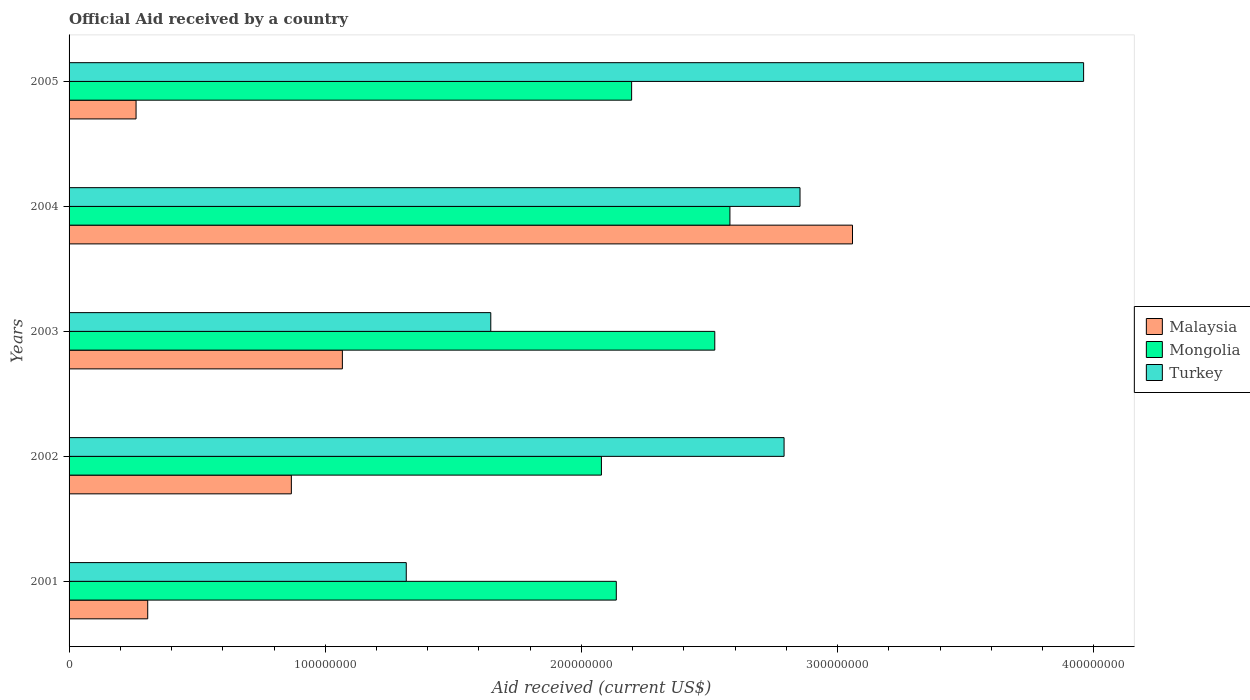How many groups of bars are there?
Your answer should be very brief. 5. How many bars are there on the 1st tick from the top?
Provide a short and direct response. 3. What is the net official aid received in Mongolia in 2005?
Make the answer very short. 2.20e+08. Across all years, what is the maximum net official aid received in Mongolia?
Provide a succinct answer. 2.58e+08. Across all years, what is the minimum net official aid received in Turkey?
Offer a very short reply. 1.32e+08. In which year was the net official aid received in Turkey minimum?
Your answer should be compact. 2001. What is the total net official aid received in Turkey in the graph?
Ensure brevity in your answer.  1.26e+09. What is the difference between the net official aid received in Mongolia in 2003 and that in 2005?
Your answer should be compact. 3.25e+07. What is the difference between the net official aid received in Malaysia in 2004 and the net official aid received in Mongolia in 2003?
Offer a very short reply. 5.38e+07. What is the average net official aid received in Malaysia per year?
Offer a terse response. 1.11e+08. In the year 2004, what is the difference between the net official aid received in Turkey and net official aid received in Mongolia?
Your answer should be compact. 2.74e+07. In how many years, is the net official aid received in Malaysia greater than 180000000 US$?
Ensure brevity in your answer.  1. What is the ratio of the net official aid received in Malaysia in 2002 to that in 2003?
Make the answer very short. 0.81. Is the net official aid received in Malaysia in 2001 less than that in 2002?
Your answer should be very brief. Yes. What is the difference between the highest and the second highest net official aid received in Turkey?
Offer a terse response. 1.11e+08. What is the difference between the highest and the lowest net official aid received in Mongolia?
Offer a terse response. 5.02e+07. In how many years, is the net official aid received in Mongolia greater than the average net official aid received in Mongolia taken over all years?
Ensure brevity in your answer.  2. What does the 1st bar from the top in 2001 represents?
Keep it short and to the point. Turkey. What does the 2nd bar from the bottom in 2004 represents?
Provide a short and direct response. Mongolia. Is it the case that in every year, the sum of the net official aid received in Malaysia and net official aid received in Mongolia is greater than the net official aid received in Turkey?
Ensure brevity in your answer.  No. Are all the bars in the graph horizontal?
Offer a terse response. Yes. How many years are there in the graph?
Offer a terse response. 5. What is the difference between two consecutive major ticks on the X-axis?
Provide a short and direct response. 1.00e+08. Does the graph contain any zero values?
Ensure brevity in your answer.  No. Does the graph contain grids?
Keep it short and to the point. No. Where does the legend appear in the graph?
Your response must be concise. Center right. How many legend labels are there?
Offer a terse response. 3. How are the legend labels stacked?
Offer a terse response. Vertical. What is the title of the graph?
Offer a very short reply. Official Aid received by a country. Does "Lithuania" appear as one of the legend labels in the graph?
Your answer should be compact. No. What is the label or title of the X-axis?
Provide a succinct answer. Aid received (current US$). What is the Aid received (current US$) in Malaysia in 2001?
Keep it short and to the point. 3.07e+07. What is the Aid received (current US$) of Mongolia in 2001?
Ensure brevity in your answer.  2.14e+08. What is the Aid received (current US$) of Turkey in 2001?
Give a very brief answer. 1.32e+08. What is the Aid received (current US$) of Malaysia in 2002?
Ensure brevity in your answer.  8.68e+07. What is the Aid received (current US$) of Mongolia in 2002?
Your response must be concise. 2.08e+08. What is the Aid received (current US$) in Turkey in 2002?
Provide a short and direct response. 2.79e+08. What is the Aid received (current US$) of Malaysia in 2003?
Ensure brevity in your answer.  1.07e+08. What is the Aid received (current US$) in Mongolia in 2003?
Keep it short and to the point. 2.52e+08. What is the Aid received (current US$) of Turkey in 2003?
Offer a very short reply. 1.65e+08. What is the Aid received (current US$) in Malaysia in 2004?
Provide a short and direct response. 3.06e+08. What is the Aid received (current US$) of Mongolia in 2004?
Offer a terse response. 2.58e+08. What is the Aid received (current US$) in Turkey in 2004?
Ensure brevity in your answer.  2.85e+08. What is the Aid received (current US$) in Malaysia in 2005?
Offer a terse response. 2.62e+07. What is the Aid received (current US$) of Mongolia in 2005?
Make the answer very short. 2.20e+08. What is the Aid received (current US$) of Turkey in 2005?
Offer a very short reply. 3.96e+08. Across all years, what is the maximum Aid received (current US$) of Malaysia?
Ensure brevity in your answer.  3.06e+08. Across all years, what is the maximum Aid received (current US$) in Mongolia?
Your response must be concise. 2.58e+08. Across all years, what is the maximum Aid received (current US$) of Turkey?
Provide a short and direct response. 3.96e+08. Across all years, what is the minimum Aid received (current US$) in Malaysia?
Give a very brief answer. 2.62e+07. Across all years, what is the minimum Aid received (current US$) in Mongolia?
Give a very brief answer. 2.08e+08. Across all years, what is the minimum Aid received (current US$) in Turkey?
Your answer should be compact. 1.32e+08. What is the total Aid received (current US$) of Malaysia in the graph?
Offer a very short reply. 5.56e+08. What is the total Aid received (current US$) of Mongolia in the graph?
Offer a very short reply. 1.15e+09. What is the total Aid received (current US$) of Turkey in the graph?
Make the answer very short. 1.26e+09. What is the difference between the Aid received (current US$) of Malaysia in 2001 and that in 2002?
Ensure brevity in your answer.  -5.61e+07. What is the difference between the Aid received (current US$) of Mongolia in 2001 and that in 2002?
Your answer should be very brief. 5.81e+06. What is the difference between the Aid received (current US$) in Turkey in 2001 and that in 2002?
Provide a succinct answer. -1.47e+08. What is the difference between the Aid received (current US$) of Malaysia in 2001 and that in 2003?
Your response must be concise. -7.60e+07. What is the difference between the Aid received (current US$) in Mongolia in 2001 and that in 2003?
Your answer should be compact. -3.84e+07. What is the difference between the Aid received (current US$) in Turkey in 2001 and that in 2003?
Provide a short and direct response. -3.30e+07. What is the difference between the Aid received (current US$) of Malaysia in 2001 and that in 2004?
Keep it short and to the point. -2.75e+08. What is the difference between the Aid received (current US$) of Mongolia in 2001 and that in 2004?
Provide a short and direct response. -4.44e+07. What is the difference between the Aid received (current US$) of Turkey in 2001 and that in 2004?
Ensure brevity in your answer.  -1.54e+08. What is the difference between the Aid received (current US$) in Malaysia in 2001 and that in 2005?
Ensure brevity in your answer.  4.55e+06. What is the difference between the Aid received (current US$) of Mongolia in 2001 and that in 2005?
Make the answer very short. -5.98e+06. What is the difference between the Aid received (current US$) in Turkey in 2001 and that in 2005?
Your response must be concise. -2.64e+08. What is the difference between the Aid received (current US$) in Malaysia in 2002 and that in 2003?
Make the answer very short. -1.99e+07. What is the difference between the Aid received (current US$) in Mongolia in 2002 and that in 2003?
Offer a terse response. -4.42e+07. What is the difference between the Aid received (current US$) of Turkey in 2002 and that in 2003?
Ensure brevity in your answer.  1.14e+08. What is the difference between the Aid received (current US$) in Malaysia in 2002 and that in 2004?
Your answer should be compact. -2.19e+08. What is the difference between the Aid received (current US$) in Mongolia in 2002 and that in 2004?
Keep it short and to the point. -5.02e+07. What is the difference between the Aid received (current US$) in Turkey in 2002 and that in 2004?
Give a very brief answer. -6.22e+06. What is the difference between the Aid received (current US$) in Malaysia in 2002 and that in 2005?
Ensure brevity in your answer.  6.06e+07. What is the difference between the Aid received (current US$) in Mongolia in 2002 and that in 2005?
Make the answer very short. -1.18e+07. What is the difference between the Aid received (current US$) of Turkey in 2002 and that in 2005?
Your response must be concise. -1.17e+08. What is the difference between the Aid received (current US$) of Malaysia in 2003 and that in 2004?
Your answer should be compact. -1.99e+08. What is the difference between the Aid received (current US$) in Mongolia in 2003 and that in 2004?
Ensure brevity in your answer.  -5.91e+06. What is the difference between the Aid received (current US$) of Turkey in 2003 and that in 2004?
Ensure brevity in your answer.  -1.21e+08. What is the difference between the Aid received (current US$) of Malaysia in 2003 and that in 2005?
Provide a succinct answer. 8.05e+07. What is the difference between the Aid received (current US$) of Mongolia in 2003 and that in 2005?
Your answer should be very brief. 3.25e+07. What is the difference between the Aid received (current US$) in Turkey in 2003 and that in 2005?
Provide a succinct answer. -2.31e+08. What is the difference between the Aid received (current US$) in Malaysia in 2004 and that in 2005?
Offer a very short reply. 2.80e+08. What is the difference between the Aid received (current US$) of Mongolia in 2004 and that in 2005?
Offer a very short reply. 3.84e+07. What is the difference between the Aid received (current US$) in Turkey in 2004 and that in 2005?
Your response must be concise. -1.11e+08. What is the difference between the Aid received (current US$) in Malaysia in 2001 and the Aid received (current US$) in Mongolia in 2002?
Your answer should be compact. -1.77e+08. What is the difference between the Aid received (current US$) of Malaysia in 2001 and the Aid received (current US$) of Turkey in 2002?
Provide a succinct answer. -2.48e+08. What is the difference between the Aid received (current US$) in Mongolia in 2001 and the Aid received (current US$) in Turkey in 2002?
Your answer should be compact. -6.55e+07. What is the difference between the Aid received (current US$) in Malaysia in 2001 and the Aid received (current US$) in Mongolia in 2003?
Ensure brevity in your answer.  -2.21e+08. What is the difference between the Aid received (current US$) of Malaysia in 2001 and the Aid received (current US$) of Turkey in 2003?
Ensure brevity in your answer.  -1.34e+08. What is the difference between the Aid received (current US$) in Mongolia in 2001 and the Aid received (current US$) in Turkey in 2003?
Keep it short and to the point. 4.90e+07. What is the difference between the Aid received (current US$) in Malaysia in 2001 and the Aid received (current US$) in Mongolia in 2004?
Offer a terse response. -2.27e+08. What is the difference between the Aid received (current US$) of Malaysia in 2001 and the Aid received (current US$) of Turkey in 2004?
Your answer should be very brief. -2.55e+08. What is the difference between the Aid received (current US$) in Mongolia in 2001 and the Aid received (current US$) in Turkey in 2004?
Offer a terse response. -7.17e+07. What is the difference between the Aid received (current US$) of Malaysia in 2001 and the Aid received (current US$) of Mongolia in 2005?
Give a very brief answer. -1.89e+08. What is the difference between the Aid received (current US$) of Malaysia in 2001 and the Aid received (current US$) of Turkey in 2005?
Provide a succinct answer. -3.65e+08. What is the difference between the Aid received (current US$) of Mongolia in 2001 and the Aid received (current US$) of Turkey in 2005?
Offer a terse response. -1.82e+08. What is the difference between the Aid received (current US$) in Malaysia in 2002 and the Aid received (current US$) in Mongolia in 2003?
Provide a short and direct response. -1.65e+08. What is the difference between the Aid received (current US$) of Malaysia in 2002 and the Aid received (current US$) of Turkey in 2003?
Ensure brevity in your answer.  -7.78e+07. What is the difference between the Aid received (current US$) of Mongolia in 2002 and the Aid received (current US$) of Turkey in 2003?
Offer a very short reply. 4.32e+07. What is the difference between the Aid received (current US$) in Malaysia in 2002 and the Aid received (current US$) in Mongolia in 2004?
Give a very brief answer. -1.71e+08. What is the difference between the Aid received (current US$) of Malaysia in 2002 and the Aid received (current US$) of Turkey in 2004?
Give a very brief answer. -1.99e+08. What is the difference between the Aid received (current US$) in Mongolia in 2002 and the Aid received (current US$) in Turkey in 2004?
Provide a short and direct response. -7.75e+07. What is the difference between the Aid received (current US$) of Malaysia in 2002 and the Aid received (current US$) of Mongolia in 2005?
Make the answer very short. -1.33e+08. What is the difference between the Aid received (current US$) in Malaysia in 2002 and the Aid received (current US$) in Turkey in 2005?
Offer a very short reply. -3.09e+08. What is the difference between the Aid received (current US$) of Mongolia in 2002 and the Aid received (current US$) of Turkey in 2005?
Keep it short and to the point. -1.88e+08. What is the difference between the Aid received (current US$) of Malaysia in 2003 and the Aid received (current US$) of Mongolia in 2004?
Your response must be concise. -1.51e+08. What is the difference between the Aid received (current US$) in Malaysia in 2003 and the Aid received (current US$) in Turkey in 2004?
Provide a short and direct response. -1.79e+08. What is the difference between the Aid received (current US$) in Mongolia in 2003 and the Aid received (current US$) in Turkey in 2004?
Your response must be concise. -3.33e+07. What is the difference between the Aid received (current US$) of Malaysia in 2003 and the Aid received (current US$) of Mongolia in 2005?
Offer a very short reply. -1.13e+08. What is the difference between the Aid received (current US$) of Malaysia in 2003 and the Aid received (current US$) of Turkey in 2005?
Offer a very short reply. -2.89e+08. What is the difference between the Aid received (current US$) of Mongolia in 2003 and the Aid received (current US$) of Turkey in 2005?
Make the answer very short. -1.44e+08. What is the difference between the Aid received (current US$) of Malaysia in 2004 and the Aid received (current US$) of Mongolia in 2005?
Offer a very short reply. 8.62e+07. What is the difference between the Aid received (current US$) of Malaysia in 2004 and the Aid received (current US$) of Turkey in 2005?
Your answer should be compact. -9.02e+07. What is the difference between the Aid received (current US$) of Mongolia in 2004 and the Aid received (current US$) of Turkey in 2005?
Make the answer very short. -1.38e+08. What is the average Aid received (current US$) in Malaysia per year?
Provide a short and direct response. 1.11e+08. What is the average Aid received (current US$) of Mongolia per year?
Your answer should be compact. 2.30e+08. What is the average Aid received (current US$) in Turkey per year?
Your answer should be compact. 2.51e+08. In the year 2001, what is the difference between the Aid received (current US$) in Malaysia and Aid received (current US$) in Mongolia?
Provide a succinct answer. -1.83e+08. In the year 2001, what is the difference between the Aid received (current US$) of Malaysia and Aid received (current US$) of Turkey?
Make the answer very short. -1.01e+08. In the year 2001, what is the difference between the Aid received (current US$) of Mongolia and Aid received (current US$) of Turkey?
Offer a terse response. 8.20e+07. In the year 2002, what is the difference between the Aid received (current US$) in Malaysia and Aid received (current US$) in Mongolia?
Offer a very short reply. -1.21e+08. In the year 2002, what is the difference between the Aid received (current US$) in Malaysia and Aid received (current US$) in Turkey?
Your answer should be compact. -1.92e+08. In the year 2002, what is the difference between the Aid received (current US$) of Mongolia and Aid received (current US$) of Turkey?
Provide a succinct answer. -7.13e+07. In the year 2003, what is the difference between the Aid received (current US$) of Malaysia and Aid received (current US$) of Mongolia?
Make the answer very short. -1.45e+08. In the year 2003, what is the difference between the Aid received (current US$) in Malaysia and Aid received (current US$) in Turkey?
Your answer should be compact. -5.79e+07. In the year 2003, what is the difference between the Aid received (current US$) in Mongolia and Aid received (current US$) in Turkey?
Keep it short and to the point. 8.74e+07. In the year 2004, what is the difference between the Aid received (current US$) in Malaysia and Aid received (current US$) in Mongolia?
Give a very brief answer. 4.78e+07. In the year 2004, what is the difference between the Aid received (current US$) in Malaysia and Aid received (current US$) in Turkey?
Your answer should be very brief. 2.05e+07. In the year 2004, what is the difference between the Aid received (current US$) of Mongolia and Aid received (current US$) of Turkey?
Give a very brief answer. -2.74e+07. In the year 2005, what is the difference between the Aid received (current US$) in Malaysia and Aid received (current US$) in Mongolia?
Keep it short and to the point. -1.93e+08. In the year 2005, what is the difference between the Aid received (current US$) of Malaysia and Aid received (current US$) of Turkey?
Offer a very short reply. -3.70e+08. In the year 2005, what is the difference between the Aid received (current US$) in Mongolia and Aid received (current US$) in Turkey?
Offer a terse response. -1.76e+08. What is the ratio of the Aid received (current US$) in Malaysia in 2001 to that in 2002?
Offer a very short reply. 0.35. What is the ratio of the Aid received (current US$) of Mongolia in 2001 to that in 2002?
Keep it short and to the point. 1.03. What is the ratio of the Aid received (current US$) of Turkey in 2001 to that in 2002?
Ensure brevity in your answer.  0.47. What is the ratio of the Aid received (current US$) in Malaysia in 2001 to that in 2003?
Your response must be concise. 0.29. What is the ratio of the Aid received (current US$) of Mongolia in 2001 to that in 2003?
Provide a succinct answer. 0.85. What is the ratio of the Aid received (current US$) in Turkey in 2001 to that in 2003?
Your response must be concise. 0.8. What is the ratio of the Aid received (current US$) in Malaysia in 2001 to that in 2004?
Provide a succinct answer. 0.1. What is the ratio of the Aid received (current US$) in Mongolia in 2001 to that in 2004?
Your response must be concise. 0.83. What is the ratio of the Aid received (current US$) in Turkey in 2001 to that in 2004?
Your response must be concise. 0.46. What is the ratio of the Aid received (current US$) in Malaysia in 2001 to that in 2005?
Provide a short and direct response. 1.17. What is the ratio of the Aid received (current US$) in Mongolia in 2001 to that in 2005?
Provide a succinct answer. 0.97. What is the ratio of the Aid received (current US$) of Turkey in 2001 to that in 2005?
Make the answer very short. 0.33. What is the ratio of the Aid received (current US$) in Malaysia in 2002 to that in 2003?
Keep it short and to the point. 0.81. What is the ratio of the Aid received (current US$) in Mongolia in 2002 to that in 2003?
Offer a very short reply. 0.82. What is the ratio of the Aid received (current US$) of Turkey in 2002 to that in 2003?
Provide a short and direct response. 1.7. What is the ratio of the Aid received (current US$) in Malaysia in 2002 to that in 2004?
Provide a succinct answer. 0.28. What is the ratio of the Aid received (current US$) in Mongolia in 2002 to that in 2004?
Make the answer very short. 0.81. What is the ratio of the Aid received (current US$) in Turkey in 2002 to that in 2004?
Offer a terse response. 0.98. What is the ratio of the Aid received (current US$) of Malaysia in 2002 to that in 2005?
Give a very brief answer. 3.32. What is the ratio of the Aid received (current US$) of Mongolia in 2002 to that in 2005?
Your response must be concise. 0.95. What is the ratio of the Aid received (current US$) of Turkey in 2002 to that in 2005?
Your answer should be compact. 0.7. What is the ratio of the Aid received (current US$) of Malaysia in 2003 to that in 2004?
Ensure brevity in your answer.  0.35. What is the ratio of the Aid received (current US$) of Mongolia in 2003 to that in 2004?
Ensure brevity in your answer.  0.98. What is the ratio of the Aid received (current US$) of Turkey in 2003 to that in 2004?
Your answer should be compact. 0.58. What is the ratio of the Aid received (current US$) in Malaysia in 2003 to that in 2005?
Ensure brevity in your answer.  4.08. What is the ratio of the Aid received (current US$) of Mongolia in 2003 to that in 2005?
Offer a terse response. 1.15. What is the ratio of the Aid received (current US$) in Turkey in 2003 to that in 2005?
Offer a terse response. 0.42. What is the ratio of the Aid received (current US$) in Malaysia in 2004 to that in 2005?
Ensure brevity in your answer.  11.69. What is the ratio of the Aid received (current US$) of Mongolia in 2004 to that in 2005?
Make the answer very short. 1.17. What is the ratio of the Aid received (current US$) of Turkey in 2004 to that in 2005?
Offer a terse response. 0.72. What is the difference between the highest and the second highest Aid received (current US$) in Malaysia?
Make the answer very short. 1.99e+08. What is the difference between the highest and the second highest Aid received (current US$) of Mongolia?
Keep it short and to the point. 5.91e+06. What is the difference between the highest and the second highest Aid received (current US$) of Turkey?
Offer a terse response. 1.11e+08. What is the difference between the highest and the lowest Aid received (current US$) in Malaysia?
Your response must be concise. 2.80e+08. What is the difference between the highest and the lowest Aid received (current US$) of Mongolia?
Offer a very short reply. 5.02e+07. What is the difference between the highest and the lowest Aid received (current US$) of Turkey?
Keep it short and to the point. 2.64e+08. 